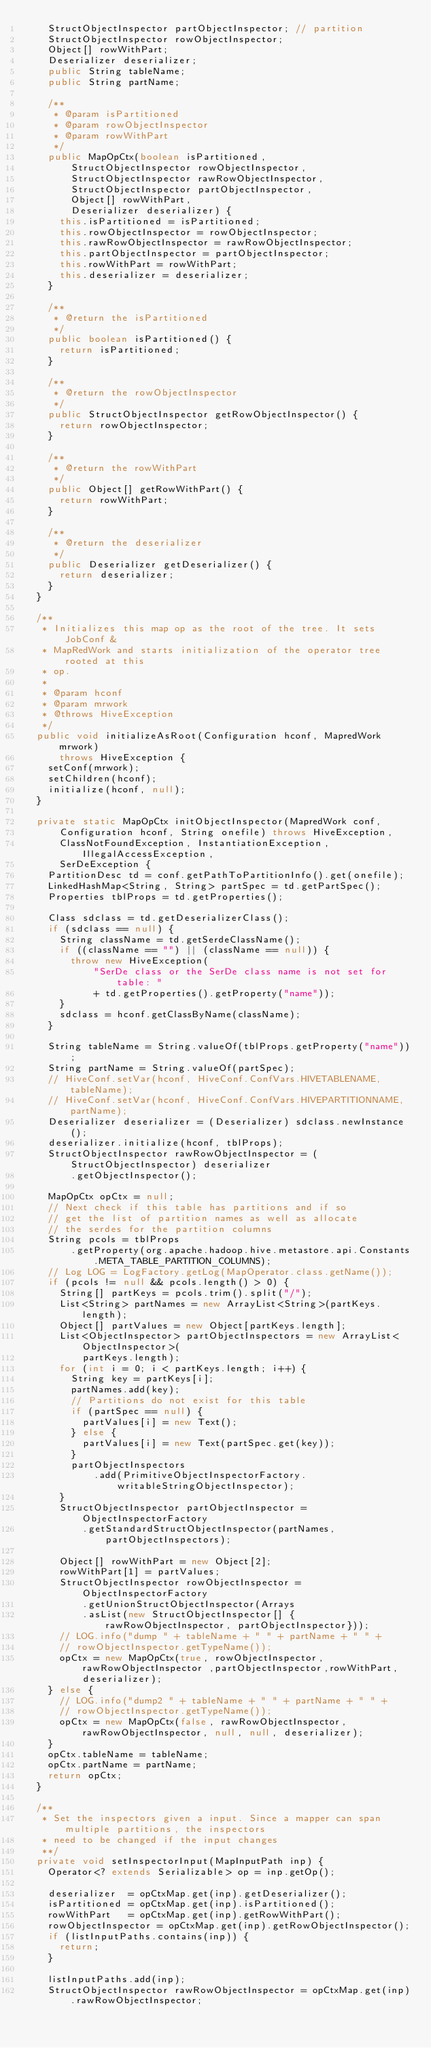<code> <loc_0><loc_0><loc_500><loc_500><_Java_>    StructObjectInspector partObjectInspector; // partition
    StructObjectInspector rowObjectInspector;
    Object[] rowWithPart;
    Deserializer deserializer;
    public String tableName;
    public String partName;

    /**
     * @param isPartitioned
     * @param rowObjectInspector
     * @param rowWithPart
     */
    public MapOpCtx(boolean isPartitioned,
        StructObjectInspector rowObjectInspector,
        StructObjectInspector rawRowObjectInspector,
        StructObjectInspector partObjectInspector,
        Object[] rowWithPart,
        Deserializer deserializer) {
      this.isPartitioned = isPartitioned;
      this.rowObjectInspector = rowObjectInspector;
      this.rawRowObjectInspector = rawRowObjectInspector;
      this.partObjectInspector = partObjectInspector;
      this.rowWithPart = rowWithPart;
      this.deserializer = deserializer;
    }

    /**
     * @return the isPartitioned
     */
    public boolean isPartitioned() {
      return isPartitioned;
    }

    /**
     * @return the rowObjectInspector
     */
    public StructObjectInspector getRowObjectInspector() {
      return rowObjectInspector;
    }

    /**
     * @return the rowWithPart
     */
    public Object[] getRowWithPart() {
      return rowWithPart;
    }

    /**
     * @return the deserializer
     */
    public Deserializer getDeserializer() {
      return deserializer;
    }
  }

  /**
   * Initializes this map op as the root of the tree. It sets JobConf &
   * MapRedWork and starts initialization of the operator tree rooted at this
   * op.
   *
   * @param hconf
   * @param mrwork
   * @throws HiveException
   */
  public void initializeAsRoot(Configuration hconf, MapredWork mrwork)
      throws HiveException {
    setConf(mrwork);
    setChildren(hconf);
    initialize(hconf, null);
  }

  private static MapOpCtx initObjectInspector(MapredWork conf,
      Configuration hconf, String onefile) throws HiveException,
      ClassNotFoundException, InstantiationException, IllegalAccessException,
      SerDeException {
    PartitionDesc td = conf.getPathToPartitionInfo().get(onefile);
    LinkedHashMap<String, String> partSpec = td.getPartSpec();
    Properties tblProps = td.getProperties();

    Class sdclass = td.getDeserializerClass();
    if (sdclass == null) {
      String className = td.getSerdeClassName();
      if ((className == "") || (className == null)) {
        throw new HiveException(
            "SerDe class or the SerDe class name is not set for table: "
            + td.getProperties().getProperty("name"));
      }
      sdclass = hconf.getClassByName(className);
    }

    String tableName = String.valueOf(tblProps.getProperty("name"));
    String partName = String.valueOf(partSpec);
    // HiveConf.setVar(hconf, HiveConf.ConfVars.HIVETABLENAME, tableName);
    // HiveConf.setVar(hconf, HiveConf.ConfVars.HIVEPARTITIONNAME, partName);
    Deserializer deserializer = (Deserializer) sdclass.newInstance();
    deserializer.initialize(hconf, tblProps);
    StructObjectInspector rawRowObjectInspector = (StructObjectInspector) deserializer
        .getObjectInspector();

    MapOpCtx opCtx = null;
    // Next check if this table has partitions and if so
    // get the list of partition names as well as allocate
    // the serdes for the partition columns
    String pcols = tblProps
        .getProperty(org.apache.hadoop.hive.metastore.api.Constants.META_TABLE_PARTITION_COLUMNS);
    // Log LOG = LogFactory.getLog(MapOperator.class.getName());
    if (pcols != null && pcols.length() > 0) {
      String[] partKeys = pcols.trim().split("/");
      List<String> partNames = new ArrayList<String>(partKeys.length);
      Object[] partValues = new Object[partKeys.length];
      List<ObjectInspector> partObjectInspectors = new ArrayList<ObjectInspector>(
          partKeys.length);
      for (int i = 0; i < partKeys.length; i++) {
        String key = partKeys[i];
        partNames.add(key);
        // Partitions do not exist for this table
        if (partSpec == null) {
          partValues[i] = new Text();
        } else {
          partValues[i] = new Text(partSpec.get(key));
        }
        partObjectInspectors
            .add(PrimitiveObjectInspectorFactory.writableStringObjectInspector);
      }
      StructObjectInspector partObjectInspector = ObjectInspectorFactory
          .getStandardStructObjectInspector(partNames, partObjectInspectors);

      Object[] rowWithPart = new Object[2];
      rowWithPart[1] = partValues;
      StructObjectInspector rowObjectInspector = ObjectInspectorFactory
          .getUnionStructObjectInspector(Arrays
          .asList(new StructObjectInspector[] {rawRowObjectInspector, partObjectInspector}));
      // LOG.info("dump " + tableName + " " + partName + " " +
      // rowObjectInspector.getTypeName());
      opCtx = new MapOpCtx(true, rowObjectInspector, rawRowObjectInspector ,partObjectInspector,rowWithPart, deserializer);
    } else {
      // LOG.info("dump2 " + tableName + " " + partName + " " +
      // rowObjectInspector.getTypeName());
      opCtx = new MapOpCtx(false, rawRowObjectInspector, rawRowObjectInspector, null, null, deserializer);
    }
    opCtx.tableName = tableName;
    opCtx.partName = partName;
    return opCtx;
  }

  /**
   * Set the inspectors given a input. Since a mapper can span multiple partitions, the inspectors
   * need to be changed if the input changes
   **/
  private void setInspectorInput(MapInputPath inp) {
    Operator<? extends Serializable> op = inp.getOp();

    deserializer  = opCtxMap.get(inp).getDeserializer();
    isPartitioned = opCtxMap.get(inp).isPartitioned();
    rowWithPart   = opCtxMap.get(inp).getRowWithPart();
    rowObjectInspector = opCtxMap.get(inp).getRowObjectInspector();
    if (listInputPaths.contains(inp)) {
      return;
    }

    listInputPaths.add(inp);
    StructObjectInspector rawRowObjectInspector = opCtxMap.get(inp).rawRowObjectInspector;</code> 